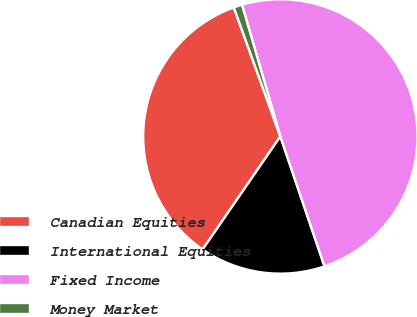Convert chart. <chart><loc_0><loc_0><loc_500><loc_500><pie_chart><fcel>Canadian Equities<fcel>International Equities<fcel>Fixed Income<fcel>Money Market<nl><fcel>34.9%<fcel>14.8%<fcel>49.3%<fcel>1.0%<nl></chart> 